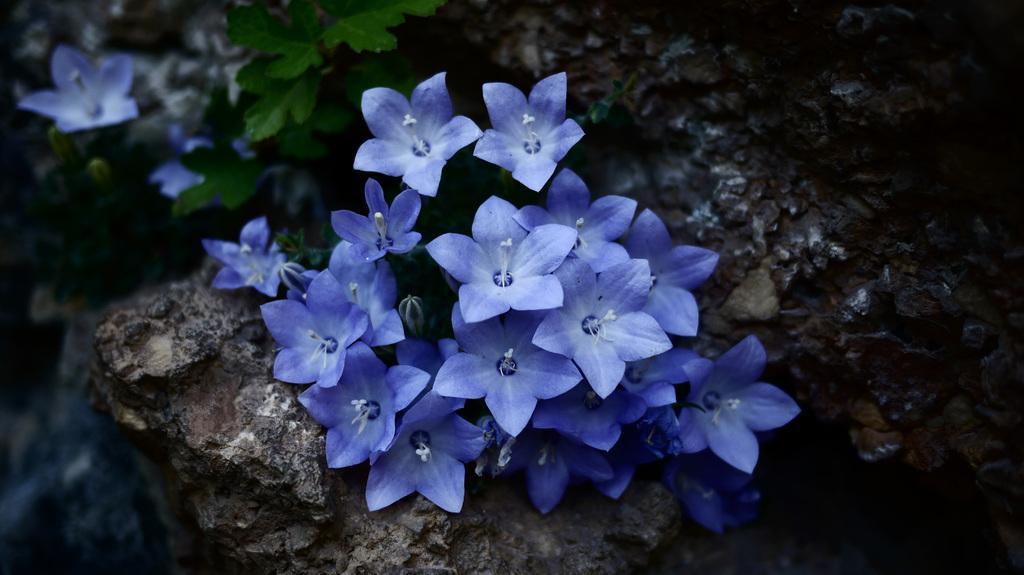Describe this image in one or two sentences. In this picture I can see a plant with buds and flowers, there is a rock , and there is blur background. 